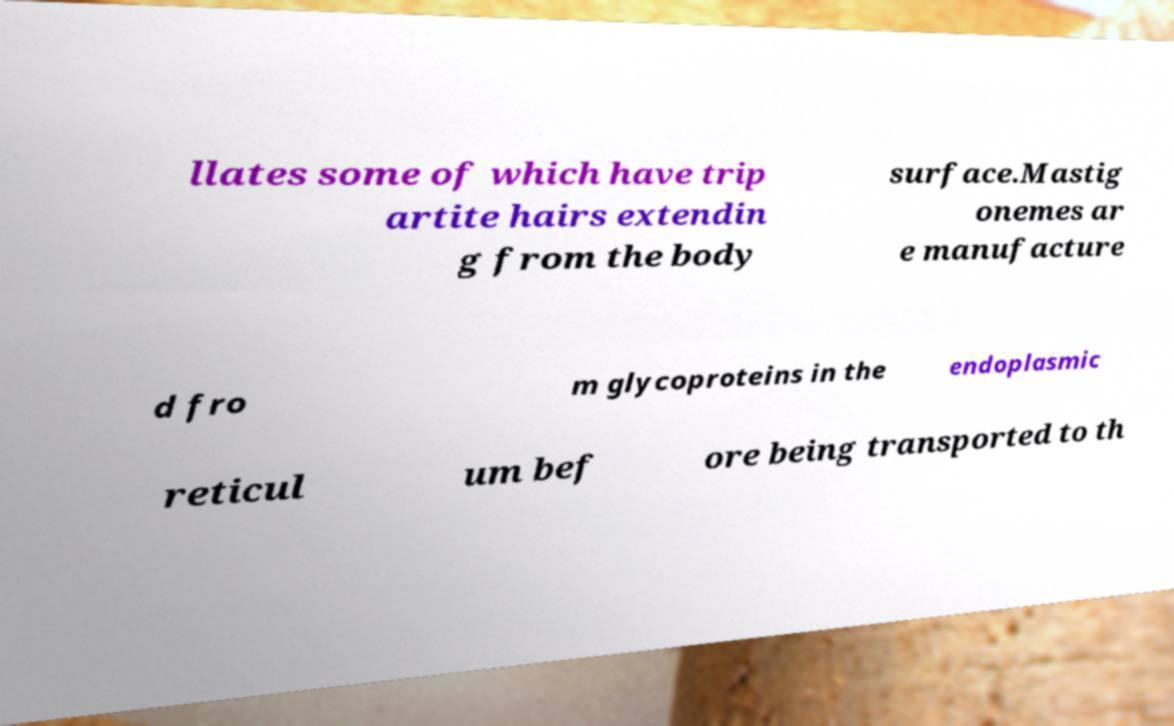Can you read and provide the text displayed in the image?This photo seems to have some interesting text. Can you extract and type it out for me? llates some of which have trip artite hairs extendin g from the body surface.Mastig onemes ar e manufacture d fro m glycoproteins in the endoplasmic reticul um bef ore being transported to th 